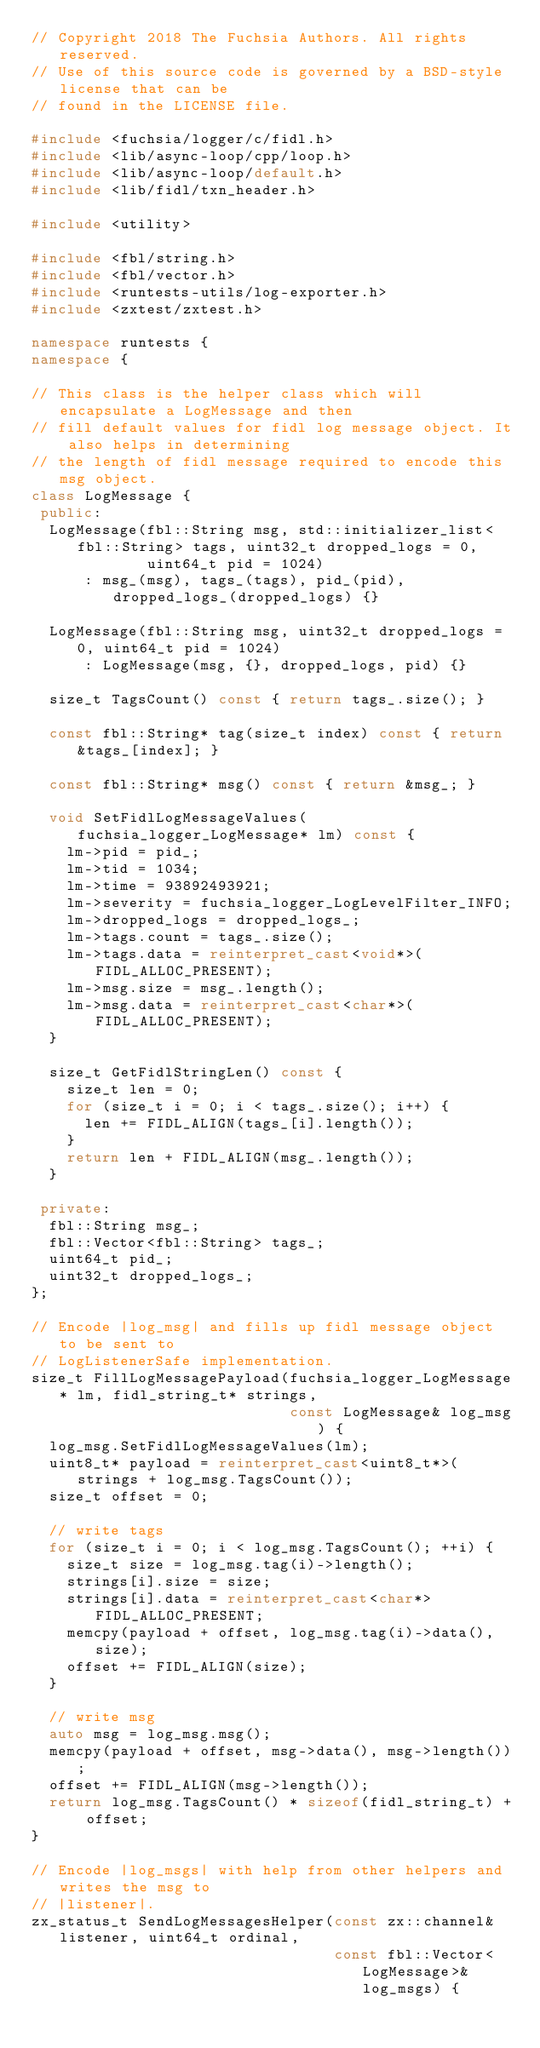Convert code to text. <code><loc_0><loc_0><loc_500><loc_500><_C++_>// Copyright 2018 The Fuchsia Authors. All rights reserved.
// Use of this source code is governed by a BSD-style license that can be
// found in the LICENSE file.

#include <fuchsia/logger/c/fidl.h>
#include <lib/async-loop/cpp/loop.h>
#include <lib/async-loop/default.h>
#include <lib/fidl/txn_header.h>

#include <utility>

#include <fbl/string.h>
#include <fbl/vector.h>
#include <runtests-utils/log-exporter.h>
#include <zxtest/zxtest.h>

namespace runtests {
namespace {

// This class is the helper class which will encapsulate a LogMessage and then
// fill default values for fidl log message object. It also helps in determining
// the length of fidl message required to encode this msg object.
class LogMessage {
 public:
  LogMessage(fbl::String msg, std::initializer_list<fbl::String> tags, uint32_t dropped_logs = 0,
             uint64_t pid = 1024)
      : msg_(msg), tags_(tags), pid_(pid), dropped_logs_(dropped_logs) {}

  LogMessage(fbl::String msg, uint32_t dropped_logs = 0, uint64_t pid = 1024)
      : LogMessage(msg, {}, dropped_logs, pid) {}

  size_t TagsCount() const { return tags_.size(); }

  const fbl::String* tag(size_t index) const { return &tags_[index]; }

  const fbl::String* msg() const { return &msg_; }

  void SetFidlLogMessageValues(fuchsia_logger_LogMessage* lm) const {
    lm->pid = pid_;
    lm->tid = 1034;
    lm->time = 93892493921;
    lm->severity = fuchsia_logger_LogLevelFilter_INFO;
    lm->dropped_logs = dropped_logs_;
    lm->tags.count = tags_.size();
    lm->tags.data = reinterpret_cast<void*>(FIDL_ALLOC_PRESENT);
    lm->msg.size = msg_.length();
    lm->msg.data = reinterpret_cast<char*>(FIDL_ALLOC_PRESENT);
  }

  size_t GetFidlStringLen() const {
    size_t len = 0;
    for (size_t i = 0; i < tags_.size(); i++) {
      len += FIDL_ALIGN(tags_[i].length());
    }
    return len + FIDL_ALIGN(msg_.length());
  }

 private:
  fbl::String msg_;
  fbl::Vector<fbl::String> tags_;
  uint64_t pid_;
  uint32_t dropped_logs_;
};

// Encode |log_msg| and fills up fidl message object to be sent to
// LogListenerSafe implementation.
size_t FillLogMessagePayload(fuchsia_logger_LogMessage* lm, fidl_string_t* strings,
                             const LogMessage& log_msg) {
  log_msg.SetFidlLogMessageValues(lm);
  uint8_t* payload = reinterpret_cast<uint8_t*>(strings + log_msg.TagsCount());
  size_t offset = 0;

  // write tags
  for (size_t i = 0; i < log_msg.TagsCount(); ++i) {
    size_t size = log_msg.tag(i)->length();
    strings[i].size = size;
    strings[i].data = reinterpret_cast<char*> FIDL_ALLOC_PRESENT;
    memcpy(payload + offset, log_msg.tag(i)->data(), size);
    offset += FIDL_ALIGN(size);
  }

  // write msg
  auto msg = log_msg.msg();
  memcpy(payload + offset, msg->data(), msg->length());
  offset += FIDL_ALIGN(msg->length());
  return log_msg.TagsCount() * sizeof(fidl_string_t) + offset;
}

// Encode |log_msgs| with help from other helpers and writes the msg to
// |listener|.
zx_status_t SendLogMessagesHelper(const zx::channel& listener, uint64_t ordinal,
                                  const fbl::Vector<LogMessage>& log_msgs) {</code> 